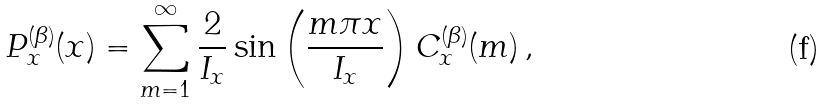Convert formula to latex. <formula><loc_0><loc_0><loc_500><loc_500>P _ { x } ^ { ( \beta ) } ( x ) = \sum _ { m = 1 } ^ { \infty } \frac { 2 } { I _ { x } } \sin \left ( \frac { m \pi x } { I _ { x } } \right ) C ^ { ( \beta ) } _ { x } ( m ) \, ,</formula> 